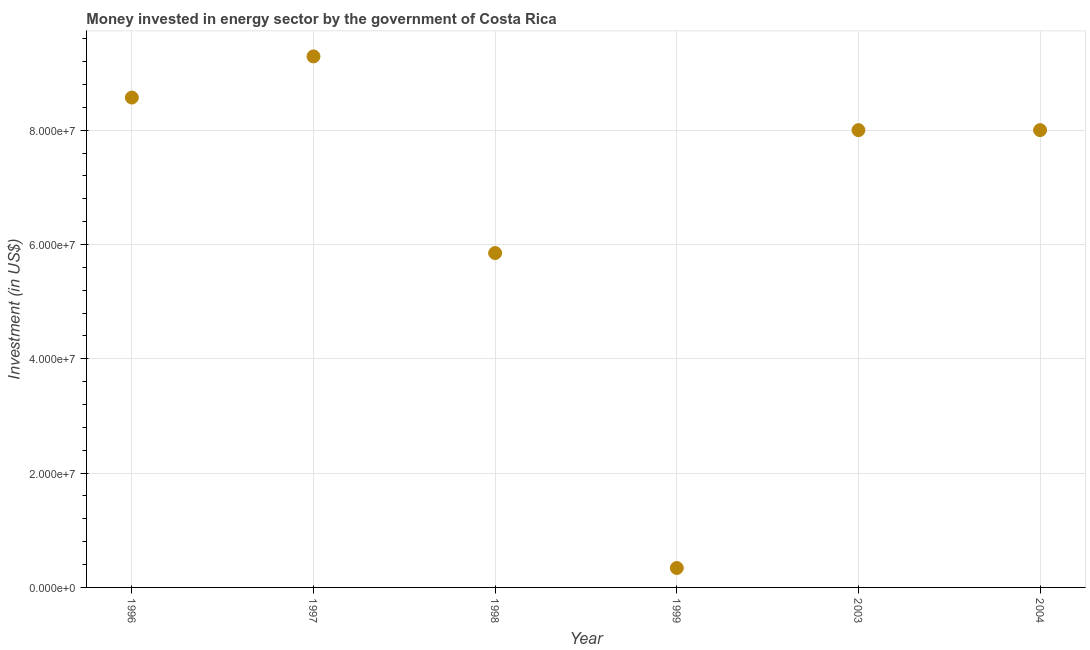What is the investment in energy in 1997?
Your answer should be compact. 9.29e+07. Across all years, what is the maximum investment in energy?
Your response must be concise. 9.29e+07. Across all years, what is the minimum investment in energy?
Provide a short and direct response. 3.40e+06. What is the sum of the investment in energy?
Your response must be concise. 4.00e+08. What is the difference between the investment in energy in 1996 and 1998?
Provide a short and direct response. 2.72e+07. What is the average investment in energy per year?
Ensure brevity in your answer.  6.68e+07. What is the median investment in energy?
Your answer should be very brief. 8.00e+07. In how many years, is the investment in energy greater than 36000000 US$?
Offer a terse response. 5. Do a majority of the years between 1996 and 1998 (inclusive) have investment in energy greater than 80000000 US$?
Your response must be concise. Yes. What is the ratio of the investment in energy in 1996 to that in 1999?
Provide a short and direct response. 25.21. What is the difference between the highest and the second highest investment in energy?
Keep it short and to the point. 7.20e+06. Is the sum of the investment in energy in 2003 and 2004 greater than the maximum investment in energy across all years?
Give a very brief answer. Yes. What is the difference between the highest and the lowest investment in energy?
Ensure brevity in your answer.  8.95e+07. In how many years, is the investment in energy greater than the average investment in energy taken over all years?
Your response must be concise. 4. How many years are there in the graph?
Offer a terse response. 6. Does the graph contain any zero values?
Your answer should be very brief. No. Does the graph contain grids?
Make the answer very short. Yes. What is the title of the graph?
Make the answer very short. Money invested in energy sector by the government of Costa Rica. What is the label or title of the X-axis?
Ensure brevity in your answer.  Year. What is the label or title of the Y-axis?
Make the answer very short. Investment (in US$). What is the Investment (in US$) in 1996?
Provide a short and direct response. 8.57e+07. What is the Investment (in US$) in 1997?
Your answer should be compact. 9.29e+07. What is the Investment (in US$) in 1998?
Provide a short and direct response. 5.85e+07. What is the Investment (in US$) in 1999?
Provide a succinct answer. 3.40e+06. What is the Investment (in US$) in 2003?
Keep it short and to the point. 8.00e+07. What is the Investment (in US$) in 2004?
Your response must be concise. 8.00e+07. What is the difference between the Investment (in US$) in 1996 and 1997?
Your answer should be very brief. -7.20e+06. What is the difference between the Investment (in US$) in 1996 and 1998?
Your answer should be compact. 2.72e+07. What is the difference between the Investment (in US$) in 1996 and 1999?
Provide a succinct answer. 8.23e+07. What is the difference between the Investment (in US$) in 1996 and 2003?
Your answer should be very brief. 5.70e+06. What is the difference between the Investment (in US$) in 1996 and 2004?
Offer a very short reply. 5.70e+06. What is the difference between the Investment (in US$) in 1997 and 1998?
Give a very brief answer. 3.44e+07. What is the difference between the Investment (in US$) in 1997 and 1999?
Make the answer very short. 8.95e+07. What is the difference between the Investment (in US$) in 1997 and 2003?
Your answer should be very brief. 1.29e+07. What is the difference between the Investment (in US$) in 1997 and 2004?
Offer a very short reply. 1.29e+07. What is the difference between the Investment (in US$) in 1998 and 1999?
Provide a succinct answer. 5.51e+07. What is the difference between the Investment (in US$) in 1998 and 2003?
Keep it short and to the point. -2.15e+07. What is the difference between the Investment (in US$) in 1998 and 2004?
Provide a short and direct response. -2.15e+07. What is the difference between the Investment (in US$) in 1999 and 2003?
Provide a short and direct response. -7.66e+07. What is the difference between the Investment (in US$) in 1999 and 2004?
Provide a succinct answer. -7.66e+07. What is the ratio of the Investment (in US$) in 1996 to that in 1997?
Make the answer very short. 0.92. What is the ratio of the Investment (in US$) in 1996 to that in 1998?
Provide a short and direct response. 1.47. What is the ratio of the Investment (in US$) in 1996 to that in 1999?
Provide a short and direct response. 25.21. What is the ratio of the Investment (in US$) in 1996 to that in 2003?
Keep it short and to the point. 1.07. What is the ratio of the Investment (in US$) in 1996 to that in 2004?
Your response must be concise. 1.07. What is the ratio of the Investment (in US$) in 1997 to that in 1998?
Provide a succinct answer. 1.59. What is the ratio of the Investment (in US$) in 1997 to that in 1999?
Keep it short and to the point. 27.32. What is the ratio of the Investment (in US$) in 1997 to that in 2003?
Ensure brevity in your answer.  1.16. What is the ratio of the Investment (in US$) in 1997 to that in 2004?
Give a very brief answer. 1.16. What is the ratio of the Investment (in US$) in 1998 to that in 1999?
Your answer should be very brief. 17.21. What is the ratio of the Investment (in US$) in 1998 to that in 2003?
Your response must be concise. 0.73. What is the ratio of the Investment (in US$) in 1998 to that in 2004?
Your response must be concise. 0.73. What is the ratio of the Investment (in US$) in 1999 to that in 2003?
Offer a very short reply. 0.04. What is the ratio of the Investment (in US$) in 1999 to that in 2004?
Your response must be concise. 0.04. What is the ratio of the Investment (in US$) in 2003 to that in 2004?
Keep it short and to the point. 1. 